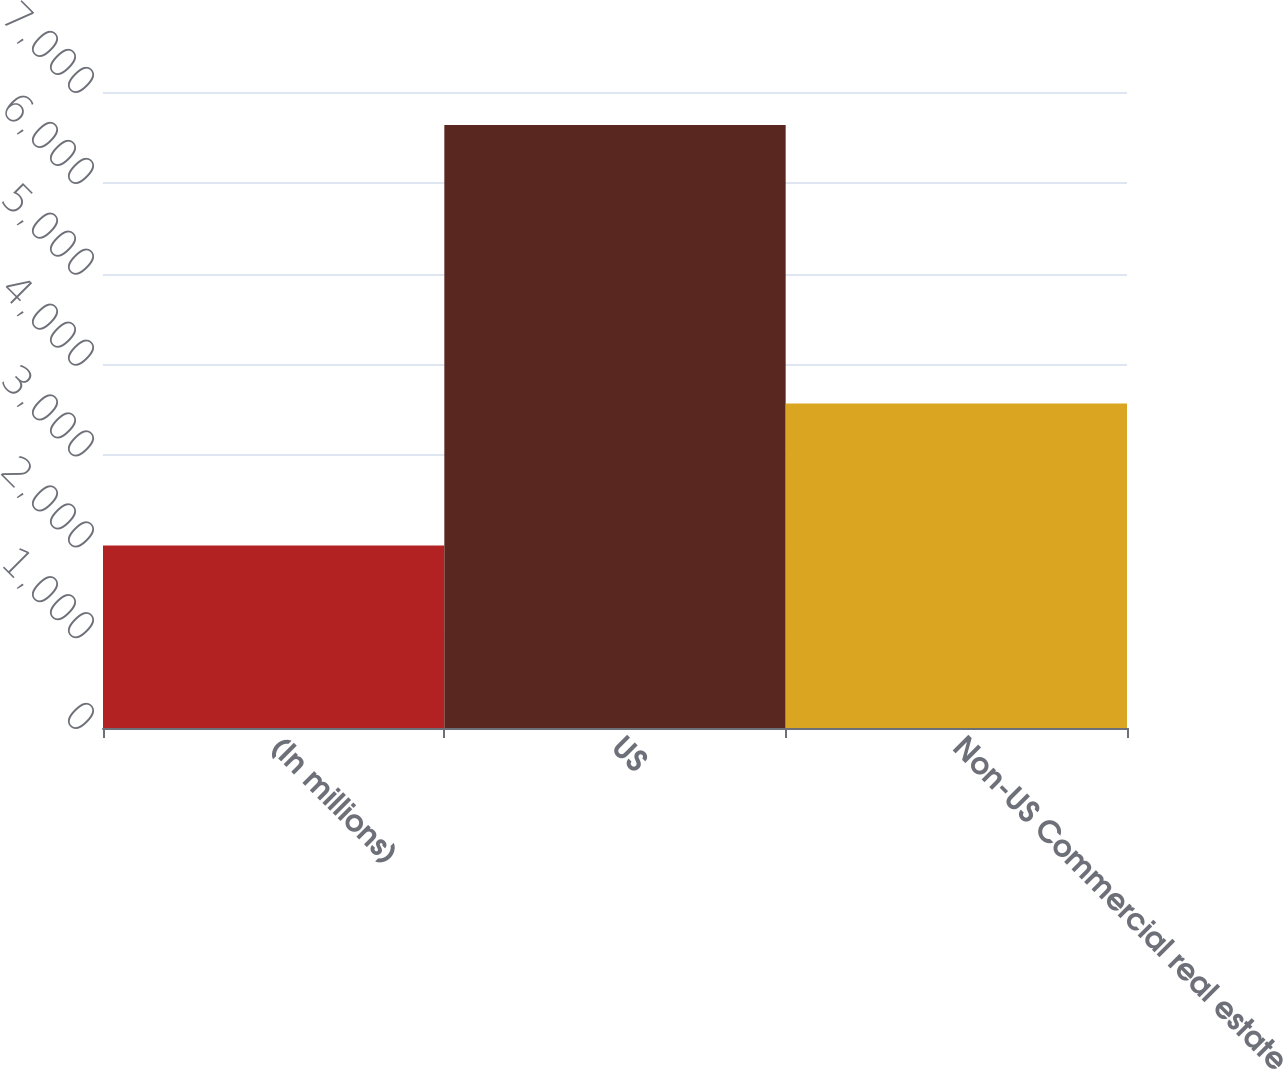Convert chart to OTSL. <chart><loc_0><loc_0><loc_500><loc_500><bar_chart><fcel>(In millions)<fcel>US<fcel>Non-US Commercial real estate<nl><fcel>2009<fcel>6637<fcel>3571<nl></chart> 